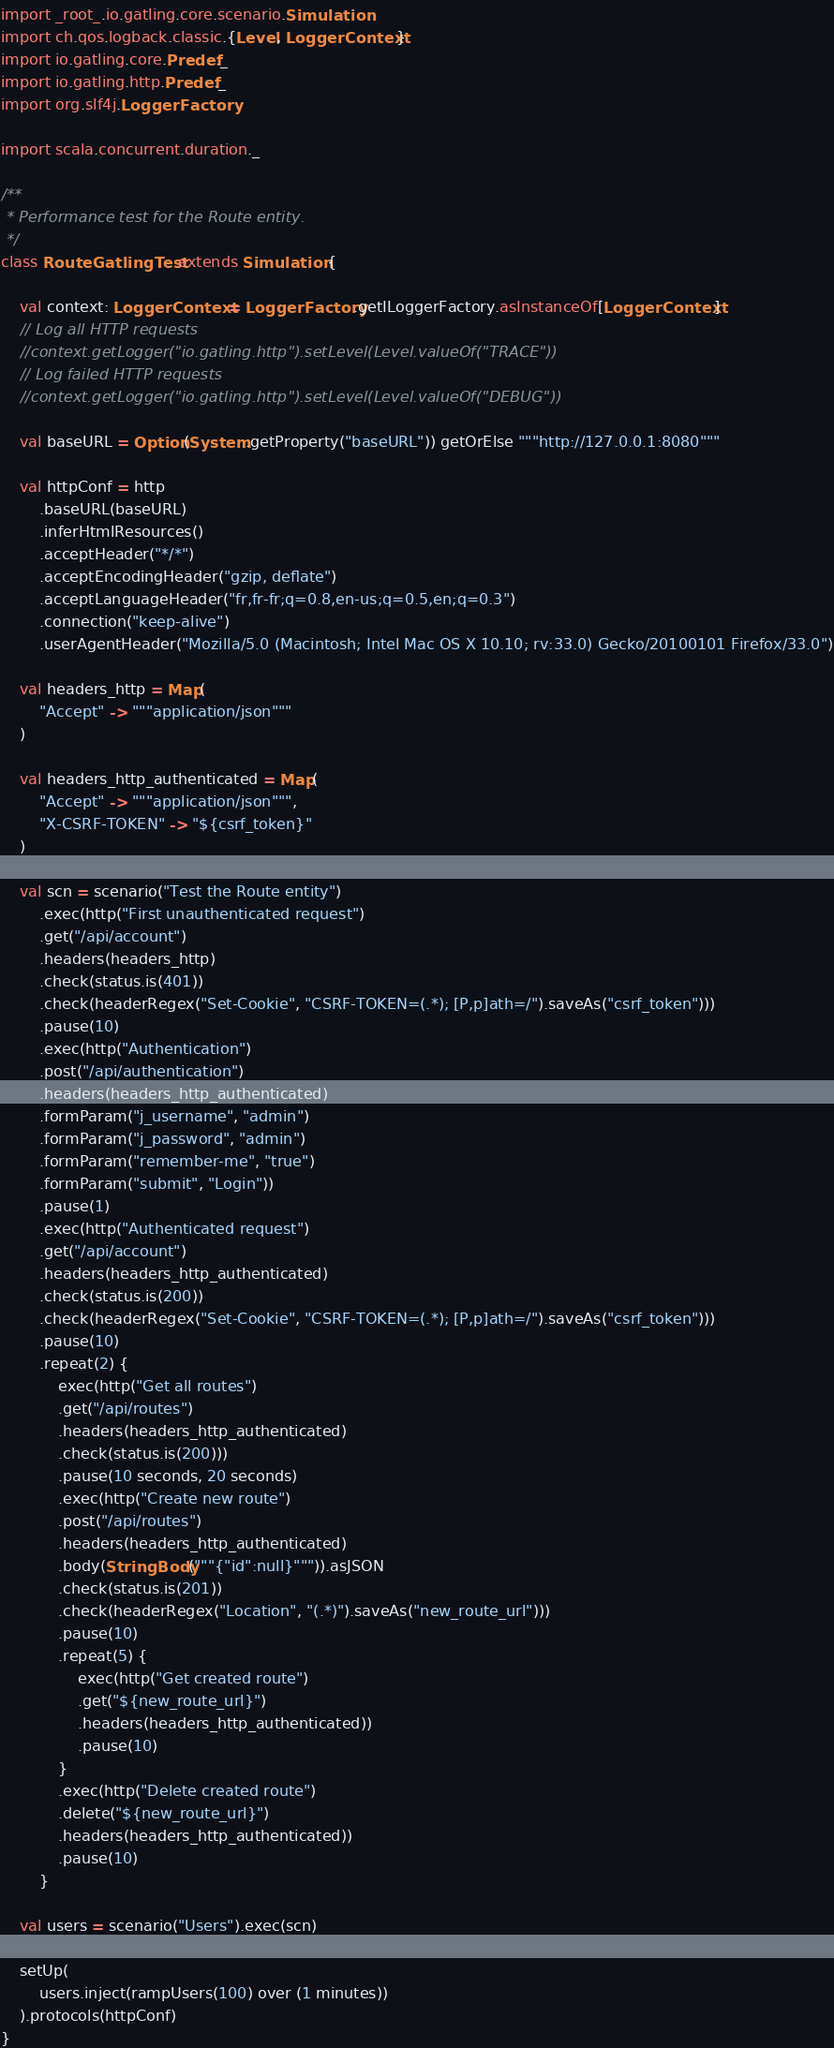Convert code to text. <code><loc_0><loc_0><loc_500><loc_500><_Scala_>import _root_.io.gatling.core.scenario.Simulation
import ch.qos.logback.classic.{Level, LoggerContext}
import io.gatling.core.Predef._
import io.gatling.http.Predef._
import org.slf4j.LoggerFactory

import scala.concurrent.duration._

/**
 * Performance test for the Route entity.
 */
class RouteGatlingTest extends Simulation {

    val context: LoggerContext = LoggerFactory.getILoggerFactory.asInstanceOf[LoggerContext]
    // Log all HTTP requests
    //context.getLogger("io.gatling.http").setLevel(Level.valueOf("TRACE"))
    // Log failed HTTP requests
    //context.getLogger("io.gatling.http").setLevel(Level.valueOf("DEBUG"))

    val baseURL = Option(System.getProperty("baseURL")) getOrElse """http://127.0.0.1:8080"""

    val httpConf = http
        .baseURL(baseURL)
        .inferHtmlResources()
        .acceptHeader("*/*")
        .acceptEncodingHeader("gzip, deflate")
        .acceptLanguageHeader("fr,fr-fr;q=0.8,en-us;q=0.5,en;q=0.3")
        .connection("keep-alive")
        .userAgentHeader("Mozilla/5.0 (Macintosh; Intel Mac OS X 10.10; rv:33.0) Gecko/20100101 Firefox/33.0")

    val headers_http = Map(
        "Accept" -> """application/json"""
    )

    val headers_http_authenticated = Map(
        "Accept" -> """application/json""",
        "X-CSRF-TOKEN" -> "${csrf_token}"
    )

    val scn = scenario("Test the Route entity")
        .exec(http("First unauthenticated request")
        .get("/api/account")
        .headers(headers_http)
        .check(status.is(401))
        .check(headerRegex("Set-Cookie", "CSRF-TOKEN=(.*); [P,p]ath=/").saveAs("csrf_token")))
        .pause(10)
        .exec(http("Authentication")
        .post("/api/authentication")
        .headers(headers_http_authenticated)
        .formParam("j_username", "admin")
        .formParam("j_password", "admin")
        .formParam("remember-me", "true")
        .formParam("submit", "Login"))
        .pause(1)
        .exec(http("Authenticated request")
        .get("/api/account")
        .headers(headers_http_authenticated)
        .check(status.is(200))
        .check(headerRegex("Set-Cookie", "CSRF-TOKEN=(.*); [P,p]ath=/").saveAs("csrf_token")))
        .pause(10)
        .repeat(2) {
            exec(http("Get all routes")
            .get("/api/routes")
            .headers(headers_http_authenticated)
            .check(status.is(200)))
            .pause(10 seconds, 20 seconds)
            .exec(http("Create new route")
            .post("/api/routes")
            .headers(headers_http_authenticated)
            .body(StringBody("""{"id":null}""")).asJSON
            .check(status.is(201))
            .check(headerRegex("Location", "(.*)").saveAs("new_route_url")))
            .pause(10)
            .repeat(5) {
                exec(http("Get created route")
                .get("${new_route_url}")
                .headers(headers_http_authenticated))
                .pause(10)
            }
            .exec(http("Delete created route")
            .delete("${new_route_url}")
            .headers(headers_http_authenticated))
            .pause(10)
        }

    val users = scenario("Users").exec(scn)

    setUp(
        users.inject(rampUsers(100) over (1 minutes))
    ).protocols(httpConf)
}
</code> 